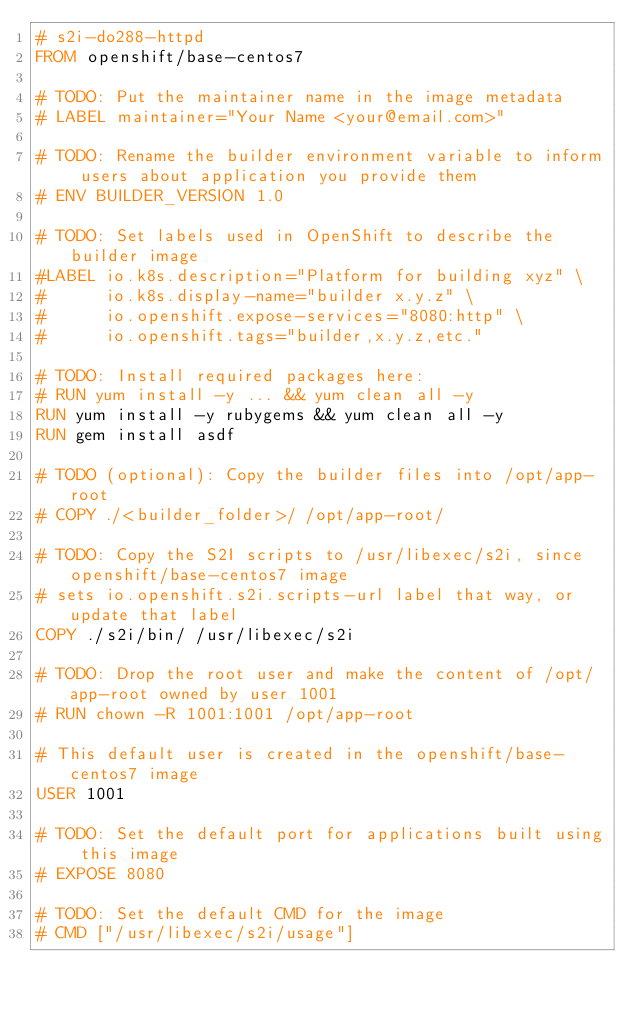Convert code to text. <code><loc_0><loc_0><loc_500><loc_500><_Dockerfile_># s2i-do288-httpd
FROM openshift/base-centos7

# TODO: Put the maintainer name in the image metadata
# LABEL maintainer="Your Name <your@email.com>"

# TODO: Rename the builder environment variable to inform users about application you provide them
# ENV BUILDER_VERSION 1.0

# TODO: Set labels used in OpenShift to describe the builder image
#LABEL io.k8s.description="Platform for building xyz" \
#      io.k8s.display-name="builder x.y.z" \
#      io.openshift.expose-services="8080:http" \
#      io.openshift.tags="builder,x.y.z,etc."

# TODO: Install required packages here:
# RUN yum install -y ... && yum clean all -y
RUN yum install -y rubygems && yum clean all -y
RUN gem install asdf

# TODO (optional): Copy the builder files into /opt/app-root
# COPY ./<builder_folder>/ /opt/app-root/

# TODO: Copy the S2I scripts to /usr/libexec/s2i, since openshift/base-centos7 image
# sets io.openshift.s2i.scripts-url label that way, or update that label
COPY ./s2i/bin/ /usr/libexec/s2i

# TODO: Drop the root user and make the content of /opt/app-root owned by user 1001
# RUN chown -R 1001:1001 /opt/app-root

# This default user is created in the openshift/base-centos7 image
USER 1001

# TODO: Set the default port for applications built using this image
# EXPOSE 8080

# TODO: Set the default CMD for the image
# CMD ["/usr/libexec/s2i/usage"]
</code> 